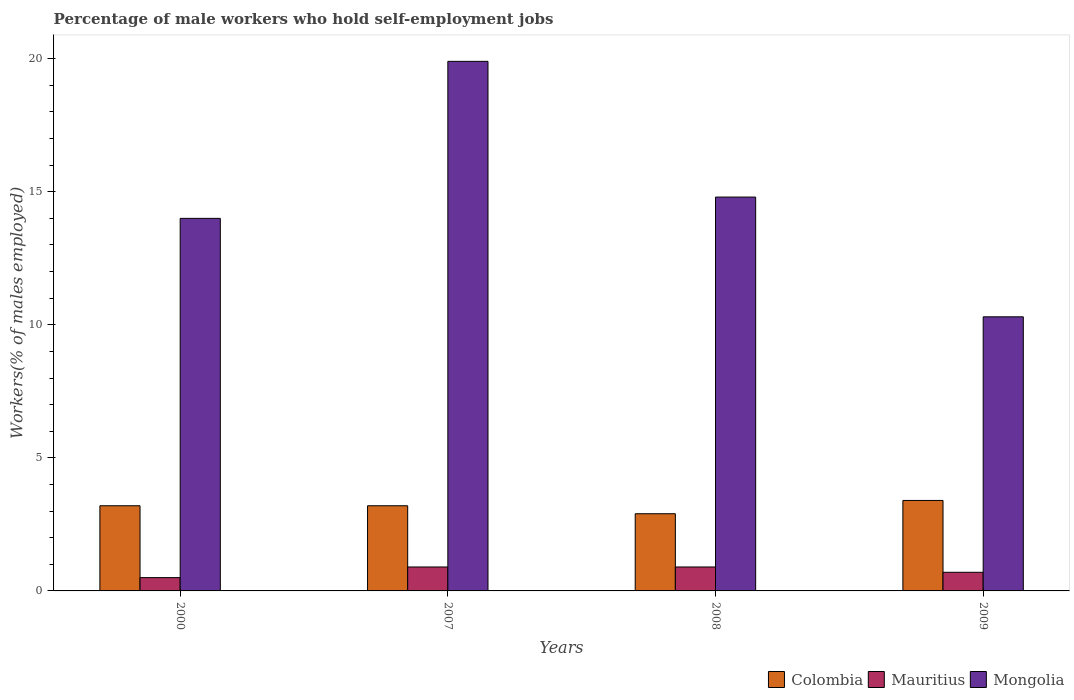How many groups of bars are there?
Your response must be concise. 4. Are the number of bars per tick equal to the number of legend labels?
Offer a terse response. Yes. Are the number of bars on each tick of the X-axis equal?
Your response must be concise. Yes. How many bars are there on the 4th tick from the right?
Your answer should be very brief. 3. What is the label of the 4th group of bars from the left?
Provide a succinct answer. 2009. In how many cases, is the number of bars for a given year not equal to the number of legend labels?
Your response must be concise. 0. What is the percentage of self-employed male workers in Mauritius in 2008?
Make the answer very short. 0.9. Across all years, what is the maximum percentage of self-employed male workers in Mauritius?
Keep it short and to the point. 0.9. Across all years, what is the minimum percentage of self-employed male workers in Mongolia?
Ensure brevity in your answer.  10.3. In which year was the percentage of self-employed male workers in Mauritius maximum?
Make the answer very short. 2007. In which year was the percentage of self-employed male workers in Mauritius minimum?
Your response must be concise. 2000. What is the total percentage of self-employed male workers in Colombia in the graph?
Offer a very short reply. 12.7. What is the difference between the percentage of self-employed male workers in Mongolia in 2007 and the percentage of self-employed male workers in Colombia in 2000?
Offer a very short reply. 16.7. What is the average percentage of self-employed male workers in Mongolia per year?
Offer a terse response. 14.75. In the year 2000, what is the difference between the percentage of self-employed male workers in Colombia and percentage of self-employed male workers in Mongolia?
Offer a very short reply. -10.8. What is the ratio of the percentage of self-employed male workers in Mauritius in 2008 to that in 2009?
Ensure brevity in your answer.  1.29. What is the difference between the highest and the lowest percentage of self-employed male workers in Mauritius?
Offer a very short reply. 0.4. In how many years, is the percentage of self-employed male workers in Mongolia greater than the average percentage of self-employed male workers in Mongolia taken over all years?
Make the answer very short. 2. What does the 2nd bar from the left in 2009 represents?
Your answer should be very brief. Mauritius. What does the 3rd bar from the right in 2009 represents?
Offer a very short reply. Colombia. Is it the case that in every year, the sum of the percentage of self-employed male workers in Colombia and percentage of self-employed male workers in Mongolia is greater than the percentage of self-employed male workers in Mauritius?
Keep it short and to the point. Yes. How many years are there in the graph?
Your answer should be compact. 4. Are the values on the major ticks of Y-axis written in scientific E-notation?
Provide a short and direct response. No. Does the graph contain grids?
Offer a very short reply. No. How many legend labels are there?
Keep it short and to the point. 3. What is the title of the graph?
Offer a very short reply. Percentage of male workers who hold self-employment jobs. Does "Korea (Republic)" appear as one of the legend labels in the graph?
Your answer should be very brief. No. What is the label or title of the Y-axis?
Keep it short and to the point. Workers(% of males employed). What is the Workers(% of males employed) of Colombia in 2000?
Provide a short and direct response. 3.2. What is the Workers(% of males employed) in Colombia in 2007?
Provide a short and direct response. 3.2. What is the Workers(% of males employed) in Mauritius in 2007?
Your response must be concise. 0.9. What is the Workers(% of males employed) of Mongolia in 2007?
Provide a short and direct response. 19.9. What is the Workers(% of males employed) in Colombia in 2008?
Make the answer very short. 2.9. What is the Workers(% of males employed) of Mauritius in 2008?
Offer a terse response. 0.9. What is the Workers(% of males employed) in Mongolia in 2008?
Give a very brief answer. 14.8. What is the Workers(% of males employed) of Colombia in 2009?
Make the answer very short. 3.4. What is the Workers(% of males employed) in Mauritius in 2009?
Provide a short and direct response. 0.7. What is the Workers(% of males employed) of Mongolia in 2009?
Offer a terse response. 10.3. Across all years, what is the maximum Workers(% of males employed) of Colombia?
Provide a short and direct response. 3.4. Across all years, what is the maximum Workers(% of males employed) of Mauritius?
Provide a short and direct response. 0.9. Across all years, what is the maximum Workers(% of males employed) in Mongolia?
Your answer should be very brief. 19.9. Across all years, what is the minimum Workers(% of males employed) of Colombia?
Give a very brief answer. 2.9. Across all years, what is the minimum Workers(% of males employed) in Mauritius?
Your answer should be compact. 0.5. Across all years, what is the minimum Workers(% of males employed) in Mongolia?
Keep it short and to the point. 10.3. What is the total Workers(% of males employed) in Mauritius in the graph?
Your answer should be compact. 3. What is the total Workers(% of males employed) in Mongolia in the graph?
Your response must be concise. 59. What is the difference between the Workers(% of males employed) in Colombia in 2000 and that in 2007?
Keep it short and to the point. 0. What is the difference between the Workers(% of males employed) in Mauritius in 2000 and that in 2007?
Provide a short and direct response. -0.4. What is the difference between the Workers(% of males employed) of Colombia in 2000 and that in 2008?
Make the answer very short. 0.3. What is the difference between the Workers(% of males employed) in Mauritius in 2000 and that in 2008?
Offer a terse response. -0.4. What is the difference between the Workers(% of males employed) in Mongolia in 2000 and that in 2008?
Make the answer very short. -0.8. What is the difference between the Workers(% of males employed) of Mauritius in 2000 and that in 2009?
Provide a short and direct response. -0.2. What is the difference between the Workers(% of males employed) in Mongolia in 2000 and that in 2009?
Keep it short and to the point. 3.7. What is the difference between the Workers(% of males employed) in Colombia in 2007 and that in 2008?
Provide a short and direct response. 0.3. What is the difference between the Workers(% of males employed) of Mauritius in 2007 and that in 2008?
Provide a short and direct response. 0. What is the difference between the Workers(% of males employed) in Colombia in 2007 and that in 2009?
Provide a succinct answer. -0.2. What is the difference between the Workers(% of males employed) of Mauritius in 2007 and that in 2009?
Give a very brief answer. 0.2. What is the difference between the Workers(% of males employed) in Mongolia in 2007 and that in 2009?
Offer a terse response. 9.6. What is the difference between the Workers(% of males employed) in Colombia in 2000 and the Workers(% of males employed) in Mongolia in 2007?
Provide a short and direct response. -16.7. What is the difference between the Workers(% of males employed) of Mauritius in 2000 and the Workers(% of males employed) of Mongolia in 2007?
Your answer should be compact. -19.4. What is the difference between the Workers(% of males employed) of Colombia in 2000 and the Workers(% of males employed) of Mongolia in 2008?
Provide a succinct answer. -11.6. What is the difference between the Workers(% of males employed) of Mauritius in 2000 and the Workers(% of males employed) of Mongolia in 2008?
Provide a succinct answer. -14.3. What is the difference between the Workers(% of males employed) of Mauritius in 2000 and the Workers(% of males employed) of Mongolia in 2009?
Provide a succinct answer. -9.8. What is the difference between the Workers(% of males employed) in Colombia in 2007 and the Workers(% of males employed) in Mauritius in 2008?
Your answer should be compact. 2.3. What is the difference between the Workers(% of males employed) in Colombia in 2007 and the Workers(% of males employed) in Mauritius in 2009?
Ensure brevity in your answer.  2.5. What is the average Workers(% of males employed) in Colombia per year?
Offer a very short reply. 3.17. What is the average Workers(% of males employed) in Mongolia per year?
Your answer should be compact. 14.75. In the year 2000, what is the difference between the Workers(% of males employed) in Colombia and Workers(% of males employed) in Mongolia?
Keep it short and to the point. -10.8. In the year 2000, what is the difference between the Workers(% of males employed) of Mauritius and Workers(% of males employed) of Mongolia?
Offer a very short reply. -13.5. In the year 2007, what is the difference between the Workers(% of males employed) in Colombia and Workers(% of males employed) in Mauritius?
Keep it short and to the point. 2.3. In the year 2007, what is the difference between the Workers(% of males employed) of Colombia and Workers(% of males employed) of Mongolia?
Ensure brevity in your answer.  -16.7. In the year 2008, what is the difference between the Workers(% of males employed) of Colombia and Workers(% of males employed) of Mauritius?
Make the answer very short. 2. In the year 2009, what is the difference between the Workers(% of males employed) of Mauritius and Workers(% of males employed) of Mongolia?
Your answer should be very brief. -9.6. What is the ratio of the Workers(% of males employed) in Mauritius in 2000 to that in 2007?
Provide a succinct answer. 0.56. What is the ratio of the Workers(% of males employed) of Mongolia in 2000 to that in 2007?
Provide a succinct answer. 0.7. What is the ratio of the Workers(% of males employed) of Colombia in 2000 to that in 2008?
Offer a terse response. 1.1. What is the ratio of the Workers(% of males employed) in Mauritius in 2000 to that in 2008?
Give a very brief answer. 0.56. What is the ratio of the Workers(% of males employed) in Mongolia in 2000 to that in 2008?
Offer a very short reply. 0.95. What is the ratio of the Workers(% of males employed) of Colombia in 2000 to that in 2009?
Ensure brevity in your answer.  0.94. What is the ratio of the Workers(% of males employed) of Mongolia in 2000 to that in 2009?
Offer a terse response. 1.36. What is the ratio of the Workers(% of males employed) of Colombia in 2007 to that in 2008?
Your response must be concise. 1.1. What is the ratio of the Workers(% of males employed) of Mauritius in 2007 to that in 2008?
Offer a terse response. 1. What is the ratio of the Workers(% of males employed) of Mongolia in 2007 to that in 2008?
Your answer should be very brief. 1.34. What is the ratio of the Workers(% of males employed) of Colombia in 2007 to that in 2009?
Make the answer very short. 0.94. What is the ratio of the Workers(% of males employed) in Mauritius in 2007 to that in 2009?
Your answer should be very brief. 1.29. What is the ratio of the Workers(% of males employed) in Mongolia in 2007 to that in 2009?
Your answer should be very brief. 1.93. What is the ratio of the Workers(% of males employed) of Colombia in 2008 to that in 2009?
Provide a short and direct response. 0.85. What is the ratio of the Workers(% of males employed) of Mauritius in 2008 to that in 2009?
Your answer should be compact. 1.29. What is the ratio of the Workers(% of males employed) in Mongolia in 2008 to that in 2009?
Provide a succinct answer. 1.44. What is the difference between the highest and the second highest Workers(% of males employed) of Colombia?
Give a very brief answer. 0.2. What is the difference between the highest and the second highest Workers(% of males employed) of Mongolia?
Your answer should be compact. 5.1. What is the difference between the highest and the lowest Workers(% of males employed) in Colombia?
Ensure brevity in your answer.  0.5. 